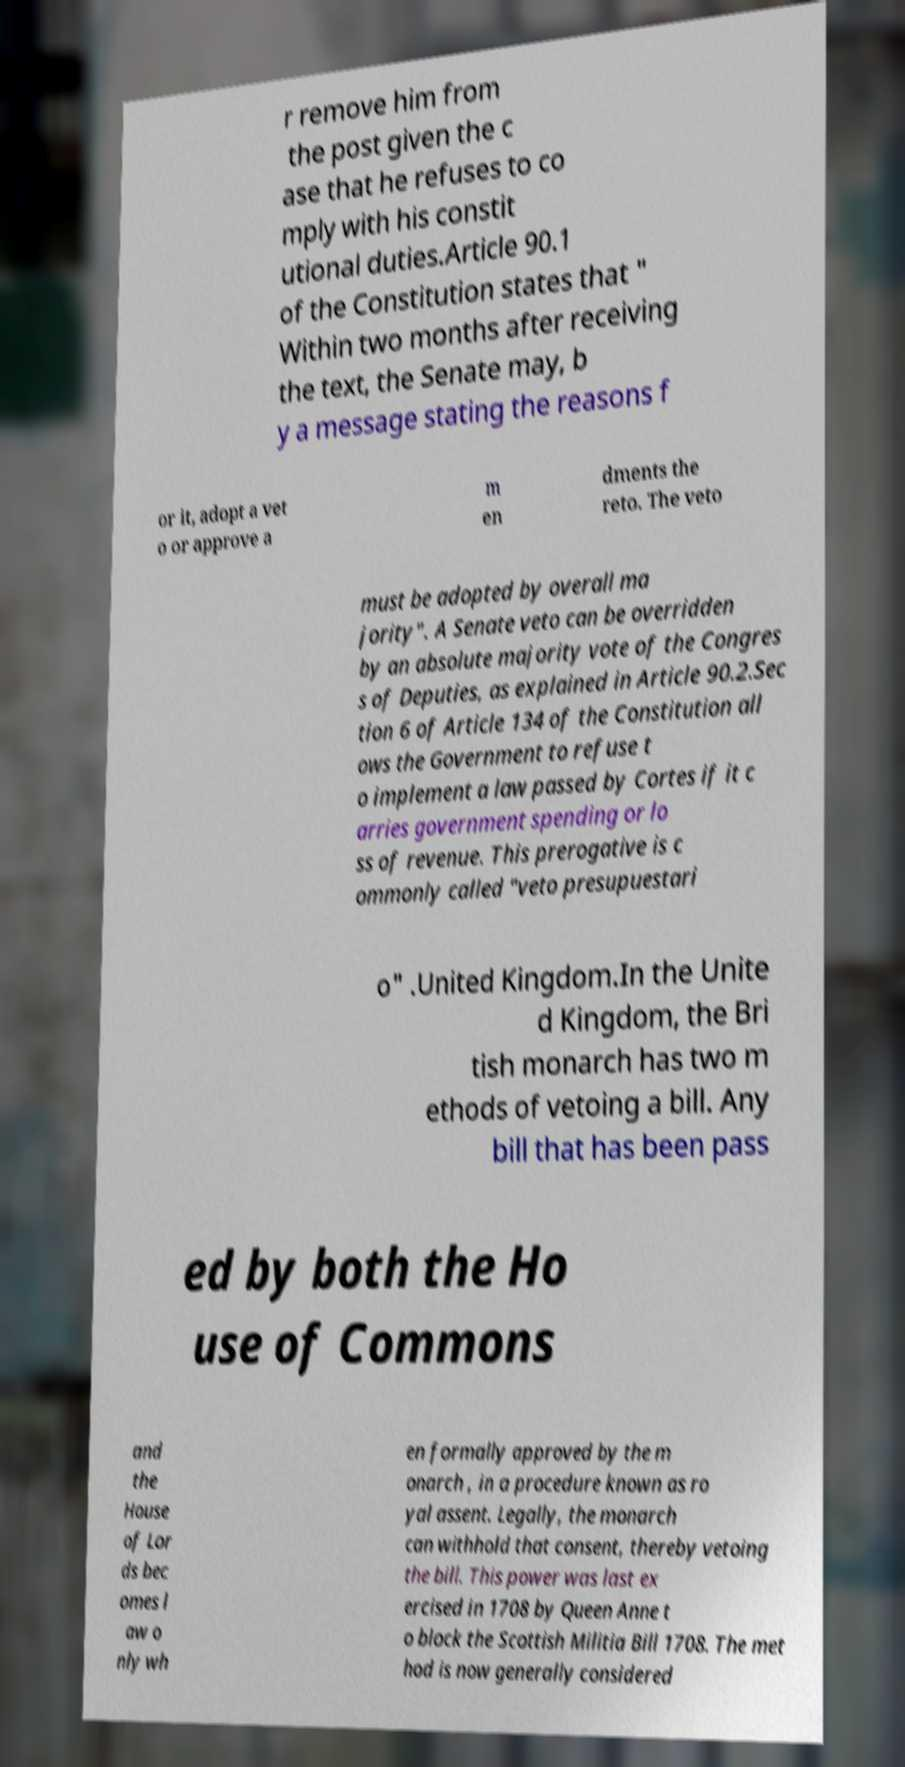Could you assist in decoding the text presented in this image and type it out clearly? r remove him from the post given the c ase that he refuses to co mply with his constit utional duties.Article 90.1 of the Constitution states that " Within two months after receiving the text, the Senate may, b y a message stating the reasons f or it, adopt a vet o or approve a m en dments the reto. The veto must be adopted by overall ma jority". A Senate veto can be overridden by an absolute majority vote of the Congres s of Deputies, as explained in Article 90.2.Sec tion 6 of Article 134 of the Constitution all ows the Government to refuse t o implement a law passed by Cortes if it c arries government spending or lo ss of revenue. This prerogative is c ommonly called "veto presupuestari o" .United Kingdom.In the Unite d Kingdom, the Bri tish monarch has two m ethods of vetoing a bill. Any bill that has been pass ed by both the Ho use of Commons and the House of Lor ds bec omes l aw o nly wh en formally approved by the m onarch , in a procedure known as ro yal assent. Legally, the monarch can withhold that consent, thereby vetoing the bill. This power was last ex ercised in 1708 by Queen Anne t o block the Scottish Militia Bill 1708. The met hod is now generally considered 